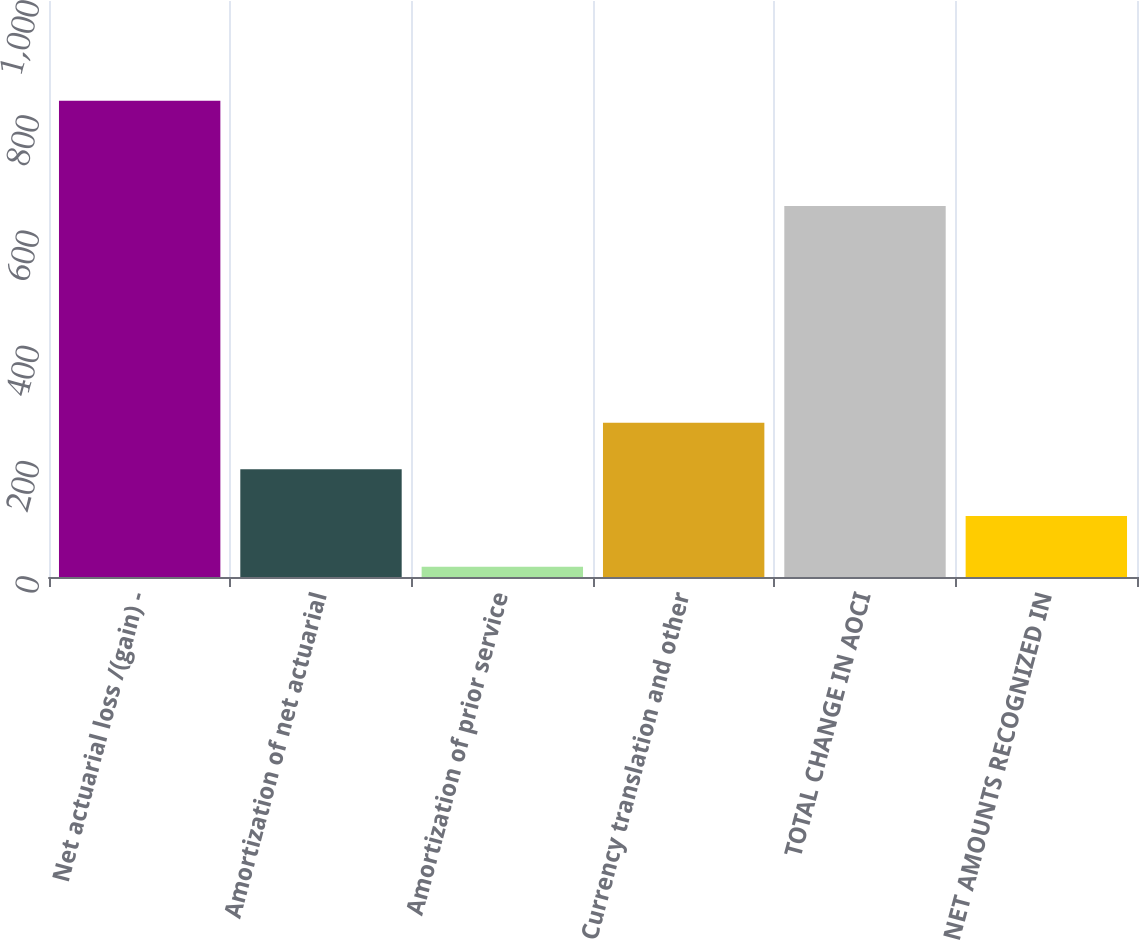<chart> <loc_0><loc_0><loc_500><loc_500><bar_chart><fcel>Net actuarial loss /(gain) -<fcel>Amortization of net actuarial<fcel>Amortization of prior service<fcel>Currency translation and other<fcel>TOTAL CHANGE IN AOCI<fcel>NET AMOUNTS RECOGNIZED IN<nl><fcel>827<fcel>186.9<fcel>18<fcel>267.8<fcel>644<fcel>106<nl></chart> 